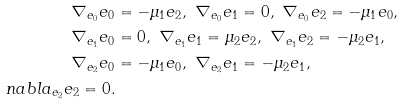<formula> <loc_0><loc_0><loc_500><loc_500>\nabla _ { e _ { 0 } } e _ { 0 } & = - \mu _ { 1 } e _ { 2 } , \ \nabla _ { e _ { 0 } } e _ { 1 } = 0 , \ \nabla _ { e _ { 0 } } e _ { 2 } = - \mu _ { 1 } e _ { 0 } , \\ \nabla _ { e _ { 1 } } e _ { 0 } & = 0 , \ \nabla _ { e _ { 1 } } e _ { 1 } = \mu _ { 2 } e _ { 2 } , \ \nabla _ { e _ { 1 } } e _ { 2 } = - \mu _ { 2 } e _ { 1 } , \\ \nabla _ { e _ { 2 } } e _ { 0 } & = - \mu _ { 1 } e _ { 0 } , \ \nabla _ { e _ { 2 } } e _ { 1 } = - \mu _ { 2 } e _ { 1 } , \\ n a b l a _ { e _ { 2 } } e _ { 2 } = 0 .</formula> 